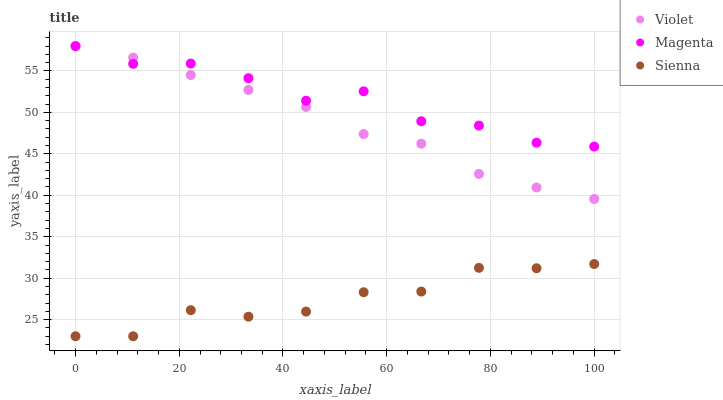Does Sienna have the minimum area under the curve?
Answer yes or no. Yes. Does Magenta have the maximum area under the curve?
Answer yes or no. Yes. Does Violet have the minimum area under the curve?
Answer yes or no. No. Does Violet have the maximum area under the curve?
Answer yes or no. No. Is Violet the smoothest?
Answer yes or no. Yes. Is Magenta the roughest?
Answer yes or no. Yes. Is Magenta the smoothest?
Answer yes or no. No. Is Violet the roughest?
Answer yes or no. No. Does Sienna have the lowest value?
Answer yes or no. Yes. Does Violet have the lowest value?
Answer yes or no. No. Does Violet have the highest value?
Answer yes or no. Yes. Does Magenta have the highest value?
Answer yes or no. No. Is Sienna less than Violet?
Answer yes or no. Yes. Is Magenta greater than Sienna?
Answer yes or no. Yes. Does Magenta intersect Violet?
Answer yes or no. Yes. Is Magenta less than Violet?
Answer yes or no. No. Is Magenta greater than Violet?
Answer yes or no. No. Does Sienna intersect Violet?
Answer yes or no. No. 